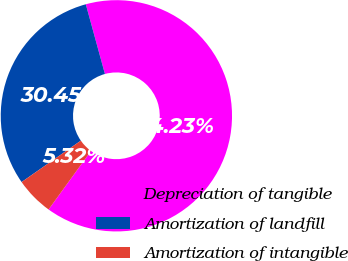<chart> <loc_0><loc_0><loc_500><loc_500><pie_chart><fcel>Depreciation of tangible<fcel>Amortization of landfill<fcel>Amortization of intangible<nl><fcel>64.23%<fcel>30.45%<fcel>5.32%<nl></chart> 